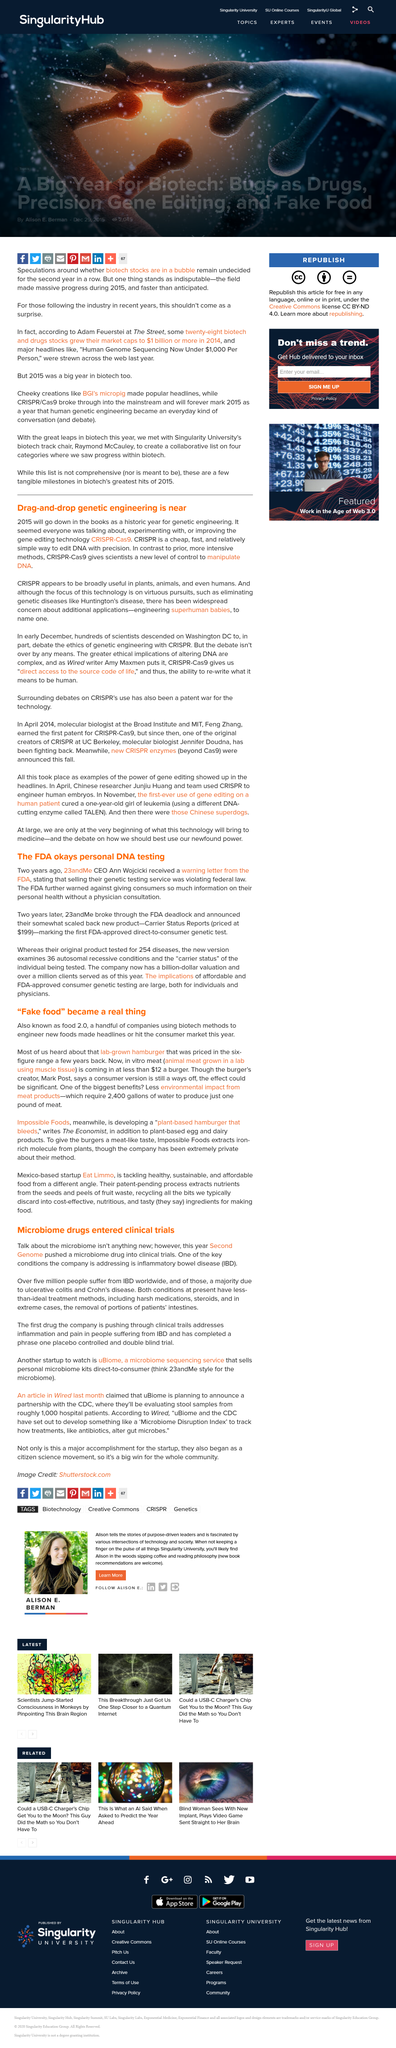Draw attention to some important aspects in this diagram. In vitro meat costs approximately 12 dollars per burger. The number of people suffering from inflammatory bowel disease (IBD) worldwide is approximately 5 million. The first drug being tested in clinical trials is designed to address inflammation and pain associated with IBD. Ann Wojcicki is the CEO of 23andMe, a company that provides genetic testing services to customers. The new test examines a total of 36 conditions. 